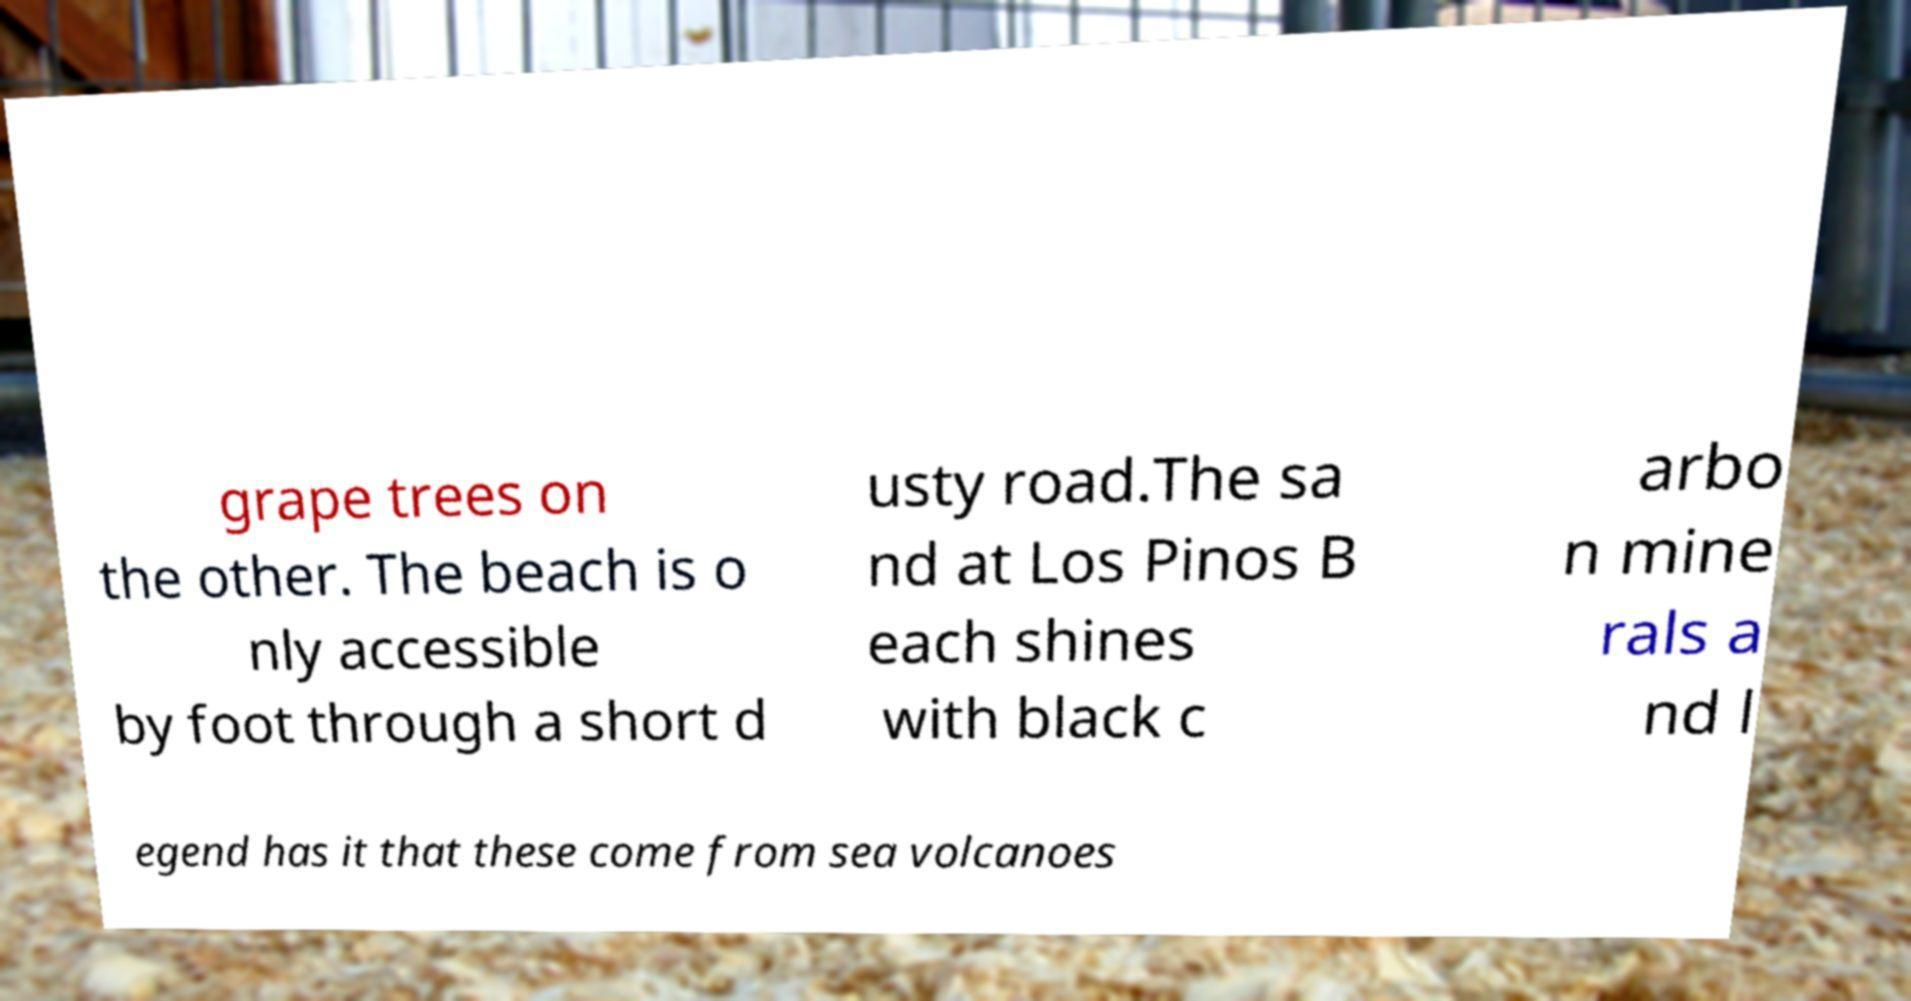Please identify and transcribe the text found in this image. grape trees on the other. The beach is o nly accessible by foot through a short d usty road.The sa nd at Los Pinos B each shines with black c arbo n mine rals a nd l egend has it that these come from sea volcanoes 